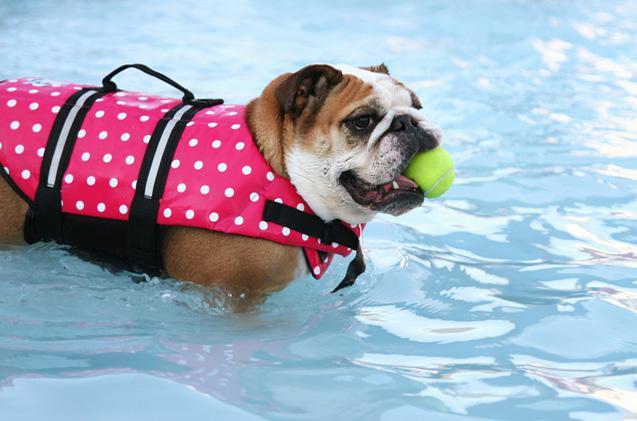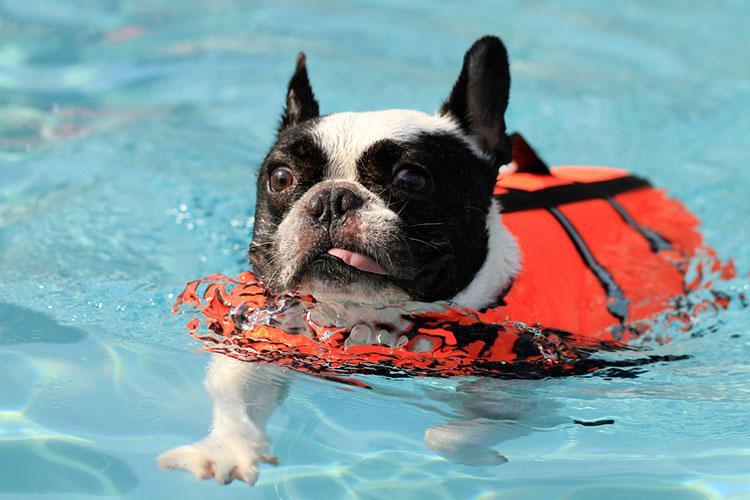The first image is the image on the left, the second image is the image on the right. For the images shown, is this caption "Each image contains one dog in a swimming pool, and the right image shows a bulldog swimming at a leftward angle and wearing an orange life vest." true? Answer yes or no. Yes. The first image is the image on the left, the second image is the image on the right. For the images displayed, is the sentence "One of the images shows a dog floating in a pool while using an inner tube." factually correct? Answer yes or no. No. 